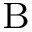<formula> <loc_0><loc_0><loc_500><loc_500>_ { B }</formula> 